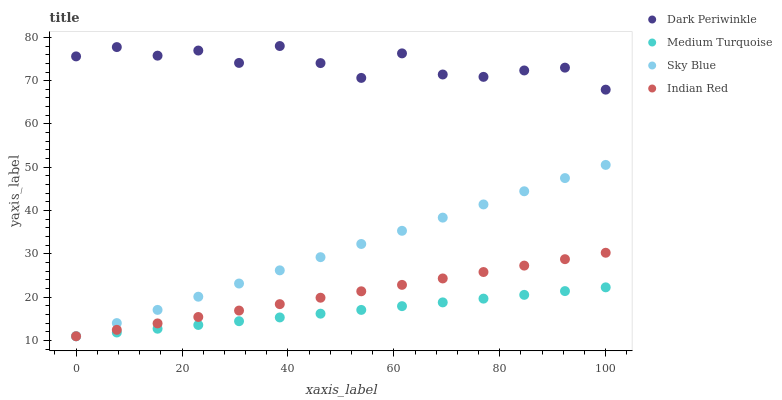Does Medium Turquoise have the minimum area under the curve?
Answer yes or no. Yes. Does Dark Periwinkle have the maximum area under the curve?
Answer yes or no. Yes. Does Sky Blue have the minimum area under the curve?
Answer yes or no. No. Does Sky Blue have the maximum area under the curve?
Answer yes or no. No. Is Medium Turquoise the smoothest?
Answer yes or no. Yes. Is Dark Periwinkle the roughest?
Answer yes or no. Yes. Is Sky Blue the smoothest?
Answer yes or no. No. Is Sky Blue the roughest?
Answer yes or no. No. Does Indian Red have the lowest value?
Answer yes or no. Yes. Does Dark Periwinkle have the lowest value?
Answer yes or no. No. Does Dark Periwinkle have the highest value?
Answer yes or no. Yes. Does Sky Blue have the highest value?
Answer yes or no. No. Is Medium Turquoise less than Dark Periwinkle?
Answer yes or no. Yes. Is Dark Periwinkle greater than Medium Turquoise?
Answer yes or no. Yes. Does Sky Blue intersect Indian Red?
Answer yes or no. Yes. Is Sky Blue less than Indian Red?
Answer yes or no. No. Is Sky Blue greater than Indian Red?
Answer yes or no. No. Does Medium Turquoise intersect Dark Periwinkle?
Answer yes or no. No. 